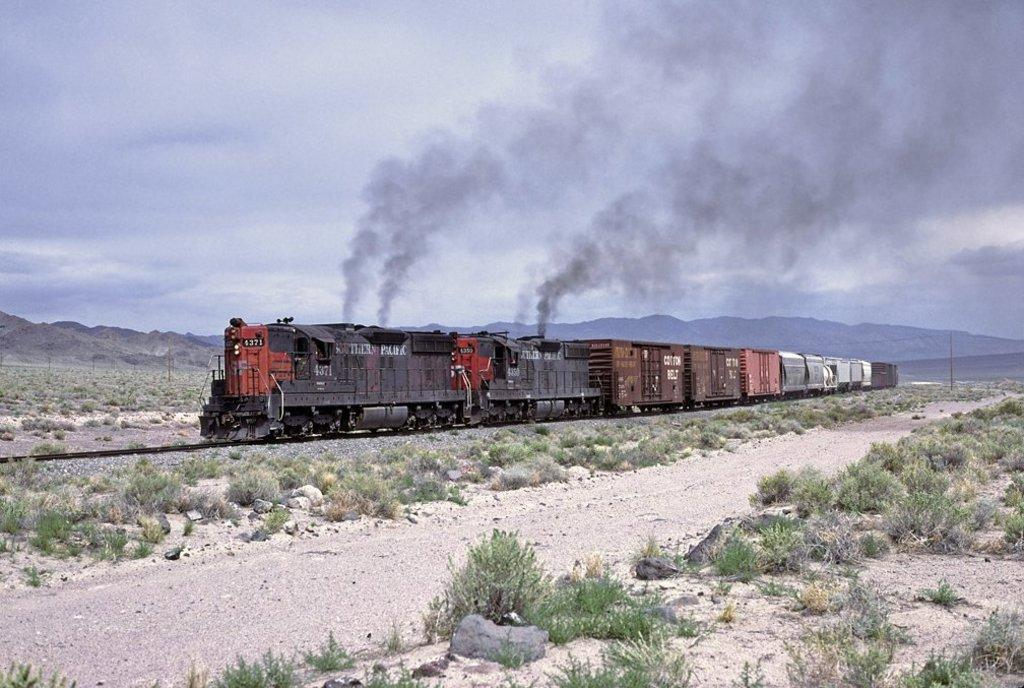What is the main subject of the image? The main subject of the image is a train running on the track. What type of natural features can be seen in the image? There are rocks, plants, bushes, and mountains visible in the image. What part of the natural environment is visible in the image? The sky is visible in the image. What type of holiday is being celebrated in the image? There is no indication of a holiday being celebrated in the image. How does the train affect the stomach of the passengers in the image? The image does not show any passengers, so it is impossible to determine how the train affects their stomachs. 